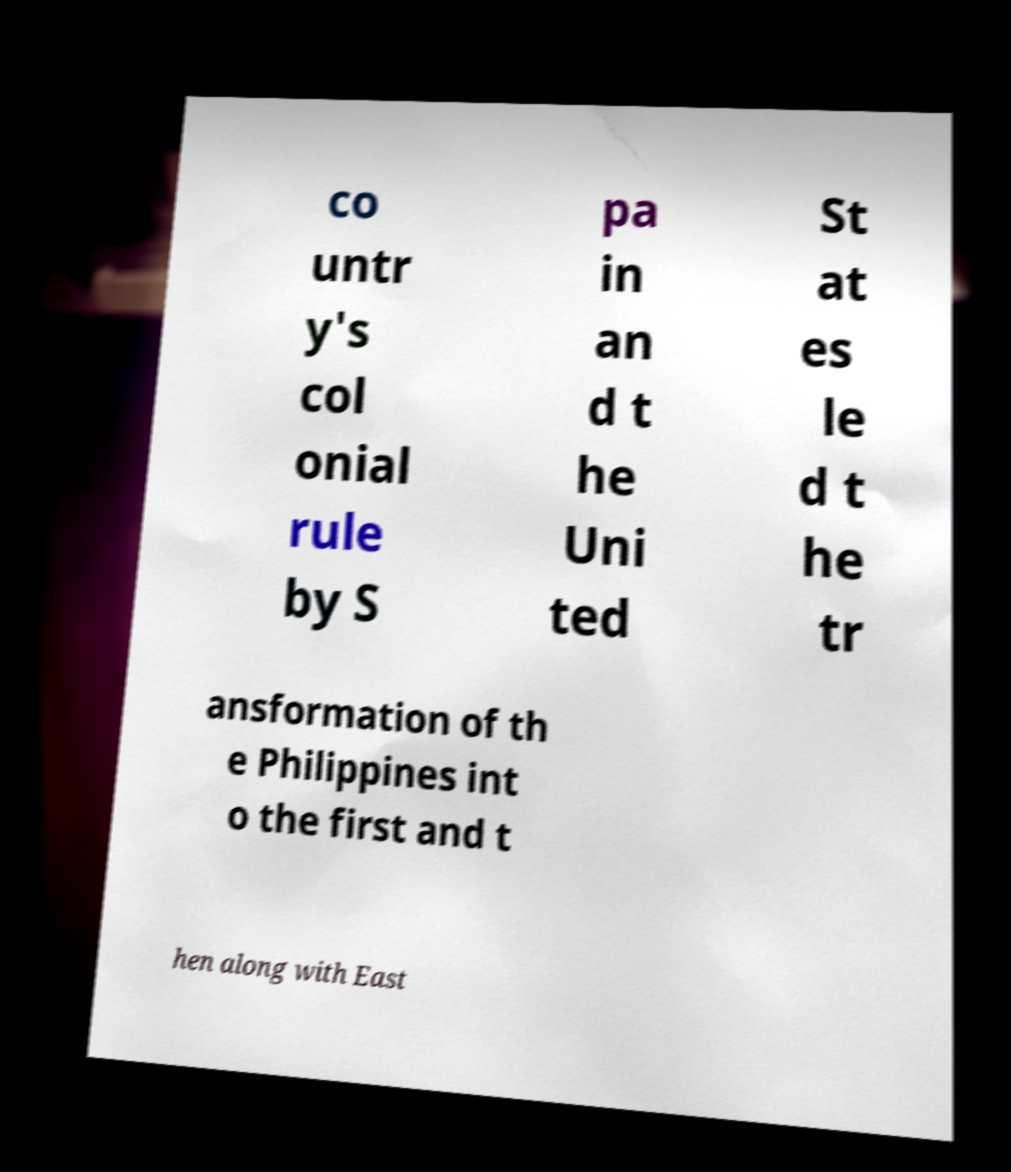Can you accurately transcribe the text from the provided image for me? co untr y's col onial rule by S pa in an d t he Uni ted St at es le d t he tr ansformation of th e Philippines int o the first and t hen along with East 